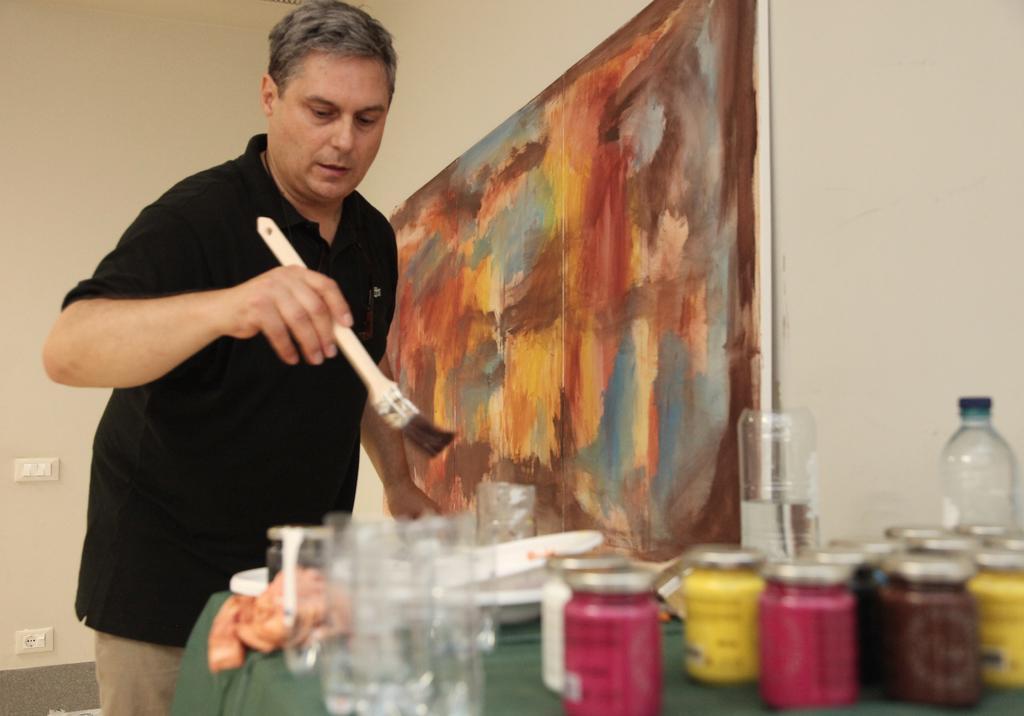Describe this image in one or two sentences. This person standing and holding brush. We can see glass,colored jars,boil,bottles and objects on the table. On the background we can see wall,painting. 